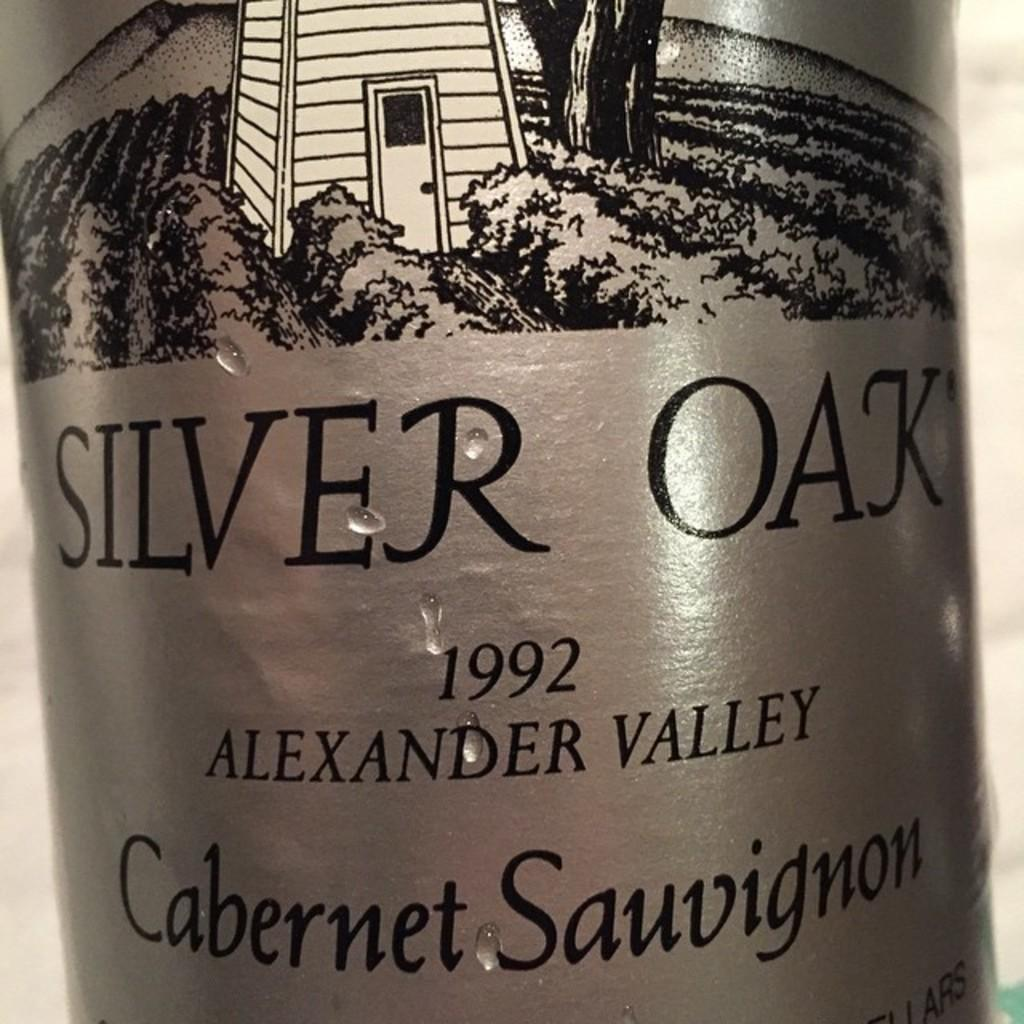<image>
Give a short and clear explanation of the subsequent image. A bottle of Silver Oak cabernet sauvignon is from 1992. 